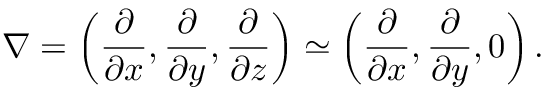Convert formula to latex. <formula><loc_0><loc_0><loc_500><loc_500>\nabla = \left ( { \frac { \partial } { \partial x } , \frac { \partial } { \partial y } , \frac { \partial } { \partial z } } \right ) \simeq \left ( { \frac { \partial } { \partial x } , \frac { \partial } { \partial y } , 0 } \right ) .</formula> 